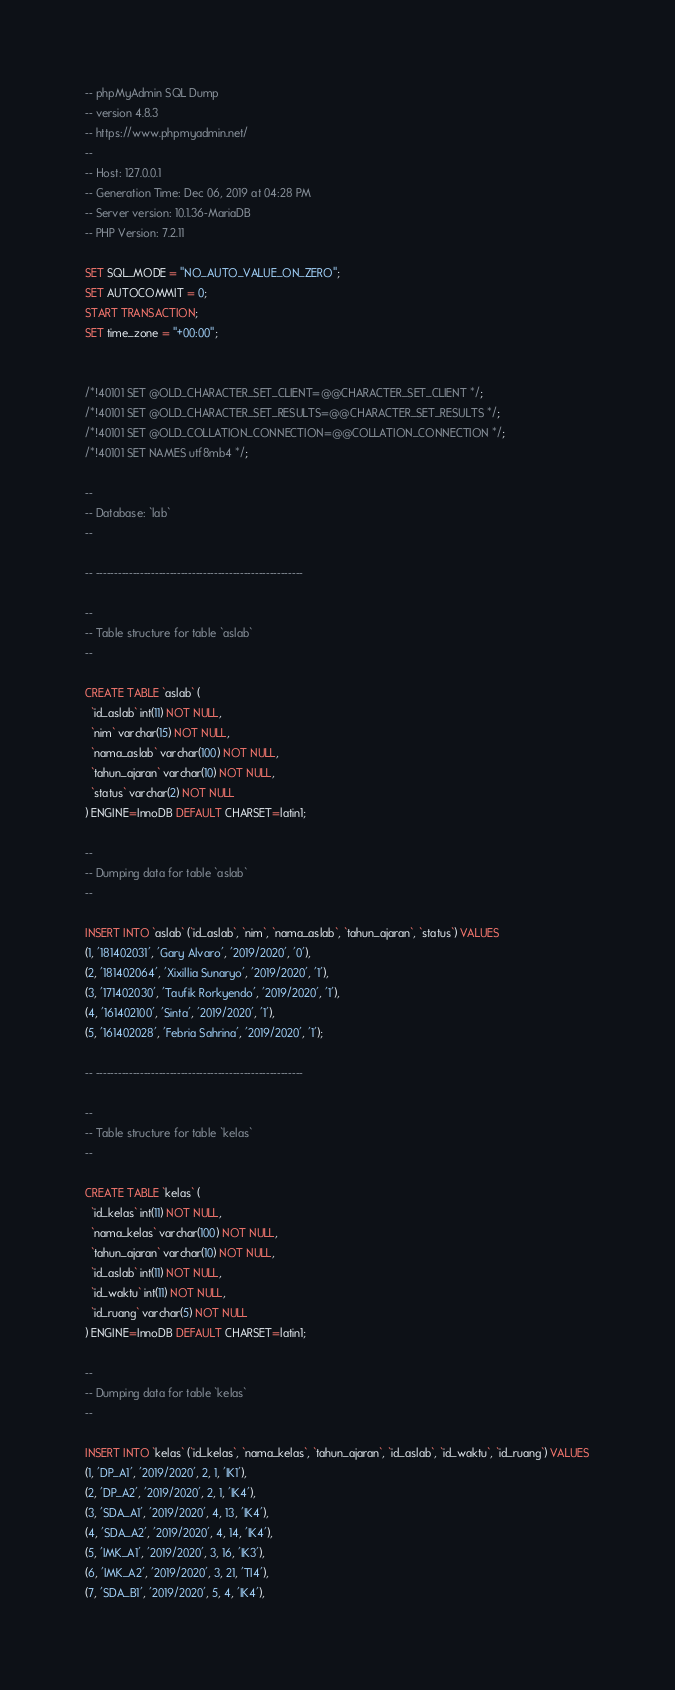<code> <loc_0><loc_0><loc_500><loc_500><_SQL_>-- phpMyAdmin SQL Dump
-- version 4.8.3
-- https://www.phpmyadmin.net/
--
-- Host: 127.0.0.1
-- Generation Time: Dec 06, 2019 at 04:28 PM
-- Server version: 10.1.36-MariaDB
-- PHP Version: 7.2.11

SET SQL_MODE = "NO_AUTO_VALUE_ON_ZERO";
SET AUTOCOMMIT = 0;
START TRANSACTION;
SET time_zone = "+00:00";


/*!40101 SET @OLD_CHARACTER_SET_CLIENT=@@CHARACTER_SET_CLIENT */;
/*!40101 SET @OLD_CHARACTER_SET_RESULTS=@@CHARACTER_SET_RESULTS */;
/*!40101 SET @OLD_COLLATION_CONNECTION=@@COLLATION_CONNECTION */;
/*!40101 SET NAMES utf8mb4 */;

--
-- Database: `lab`
--

-- --------------------------------------------------------

--
-- Table structure for table `aslab`
--

CREATE TABLE `aslab` (
  `id_aslab` int(11) NOT NULL,
  `nim` varchar(15) NOT NULL,
  `nama_aslab` varchar(100) NOT NULL,
  `tahun_ajaran` varchar(10) NOT NULL,
  `status` varchar(2) NOT NULL
) ENGINE=InnoDB DEFAULT CHARSET=latin1;

--
-- Dumping data for table `aslab`
--

INSERT INTO `aslab` (`id_aslab`, `nim`, `nama_aslab`, `tahun_ajaran`, `status`) VALUES
(1, '181402031', 'Gary Alvaro', '2019/2020', '0'),
(2, '181402064', 'Xixillia Sunaryo', '2019/2020', '1'),
(3, '171402030', 'Taufik Rorkyendo', '2019/2020', '1'),
(4, '161402100', 'Sinta', '2019/2020', '1'),
(5, '161402028', 'Febria Sahrina', '2019/2020', '1');

-- --------------------------------------------------------

--
-- Table structure for table `kelas`
--

CREATE TABLE `kelas` (
  `id_kelas` int(11) NOT NULL,
  `nama_kelas` varchar(100) NOT NULL,
  `tahun_ajaran` varchar(10) NOT NULL,
  `id_aslab` int(11) NOT NULL,
  `id_waktu` int(11) NOT NULL,
  `id_ruang` varchar(5) NOT NULL
) ENGINE=InnoDB DEFAULT CHARSET=latin1;

--
-- Dumping data for table `kelas`
--

INSERT INTO `kelas` (`id_kelas`, `nama_kelas`, `tahun_ajaran`, `id_aslab`, `id_waktu`, `id_ruang`) VALUES
(1, 'DP_A1', '2019/2020', 2, 1, 'IK1'),
(2, 'DP_A2', '2019/2020', 2, 1, 'IK4'),
(3, 'SDA_A1', '2019/2020', 4, 13, 'IK4'),
(4, 'SDA_A2', '2019/2020', 4, 14, 'IK4'),
(5, 'IMK_A1', '2019/2020', 3, 16, 'IK3'),
(6, 'IMK_A2', '2019/2020', 3, 21, 'TI4'),
(7, 'SDA_B1', '2019/2020', 5, 4, 'IK4'),</code> 